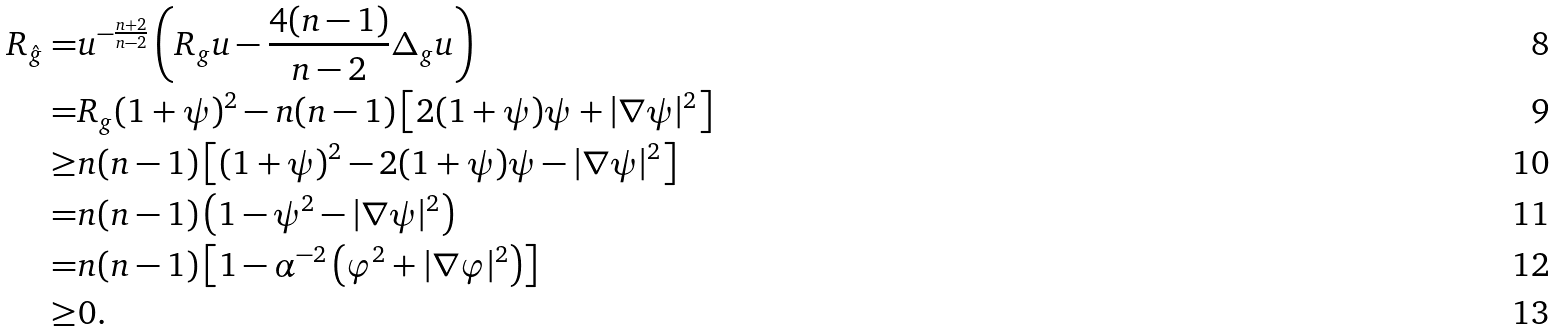Convert formula to latex. <formula><loc_0><loc_0><loc_500><loc_500>R _ { \hat { g } } = & u ^ { - \frac { n + 2 } { n - 2 } } \left ( R _ { g } u - \frac { 4 ( n - 1 ) } { n - 2 } \Delta _ { g } u \right ) \\ = & R _ { g } ( 1 + \psi ) ^ { 2 } - n ( n - 1 ) \left [ 2 ( 1 + \psi ) \psi + | \nabla \psi | ^ { 2 } \right ] \\ \geq & n ( n - 1 ) \left [ ( 1 + \psi ) ^ { 2 } - 2 ( 1 + \psi ) \psi - | \nabla \psi | ^ { 2 } \right ] \\ = & n ( n - 1 ) \left ( 1 - \psi ^ { 2 } - | \nabla \psi | ^ { 2 } \right ) \\ = & n ( n - 1 ) \left [ 1 - \alpha ^ { - 2 } \left ( \varphi ^ { 2 } + | \nabla \varphi | ^ { 2 } \right ) \right ] \\ \geq & 0 .</formula> 